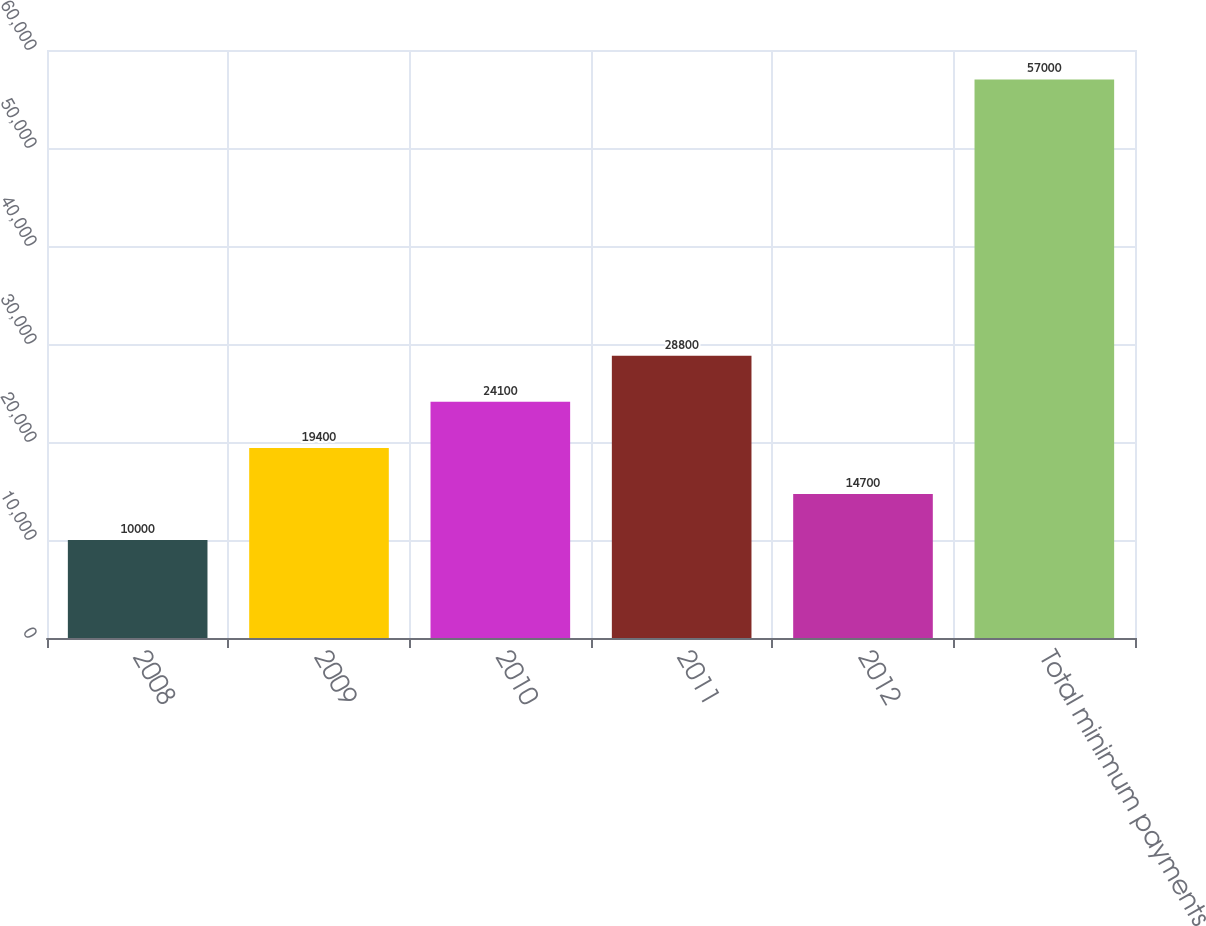<chart> <loc_0><loc_0><loc_500><loc_500><bar_chart><fcel>2008<fcel>2009<fcel>2010<fcel>2011<fcel>2012<fcel>Total minimum payments<nl><fcel>10000<fcel>19400<fcel>24100<fcel>28800<fcel>14700<fcel>57000<nl></chart> 